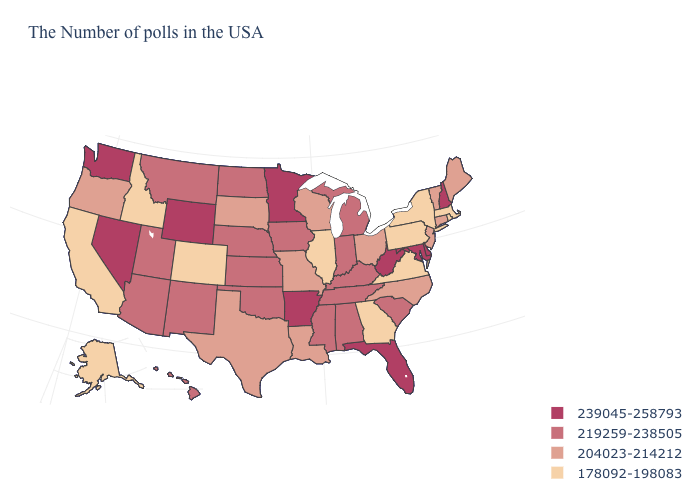Is the legend a continuous bar?
Keep it brief. No. What is the value of Montana?
Give a very brief answer. 219259-238505. What is the value of Nebraska?
Keep it brief. 219259-238505. Does Oregon have the highest value in the USA?
Short answer required. No. Name the states that have a value in the range 239045-258793?
Be succinct. New Hampshire, Delaware, Maryland, West Virginia, Florida, Arkansas, Minnesota, Wyoming, Nevada, Washington. Does West Virginia have the highest value in the USA?
Concise answer only. Yes. Does Rhode Island have the same value as Massachusetts?
Be succinct. Yes. Is the legend a continuous bar?
Give a very brief answer. No. What is the value of Nevada?
Concise answer only. 239045-258793. What is the value of Wisconsin?
Be succinct. 204023-214212. Does Hawaii have the same value as Wyoming?
Write a very short answer. No. Does South Carolina have a higher value than Arizona?
Quick response, please. No. What is the value of Indiana?
Give a very brief answer. 219259-238505. Among the states that border South Carolina , which have the lowest value?
Quick response, please. Georgia. What is the lowest value in states that border North Carolina?
Write a very short answer. 178092-198083. 